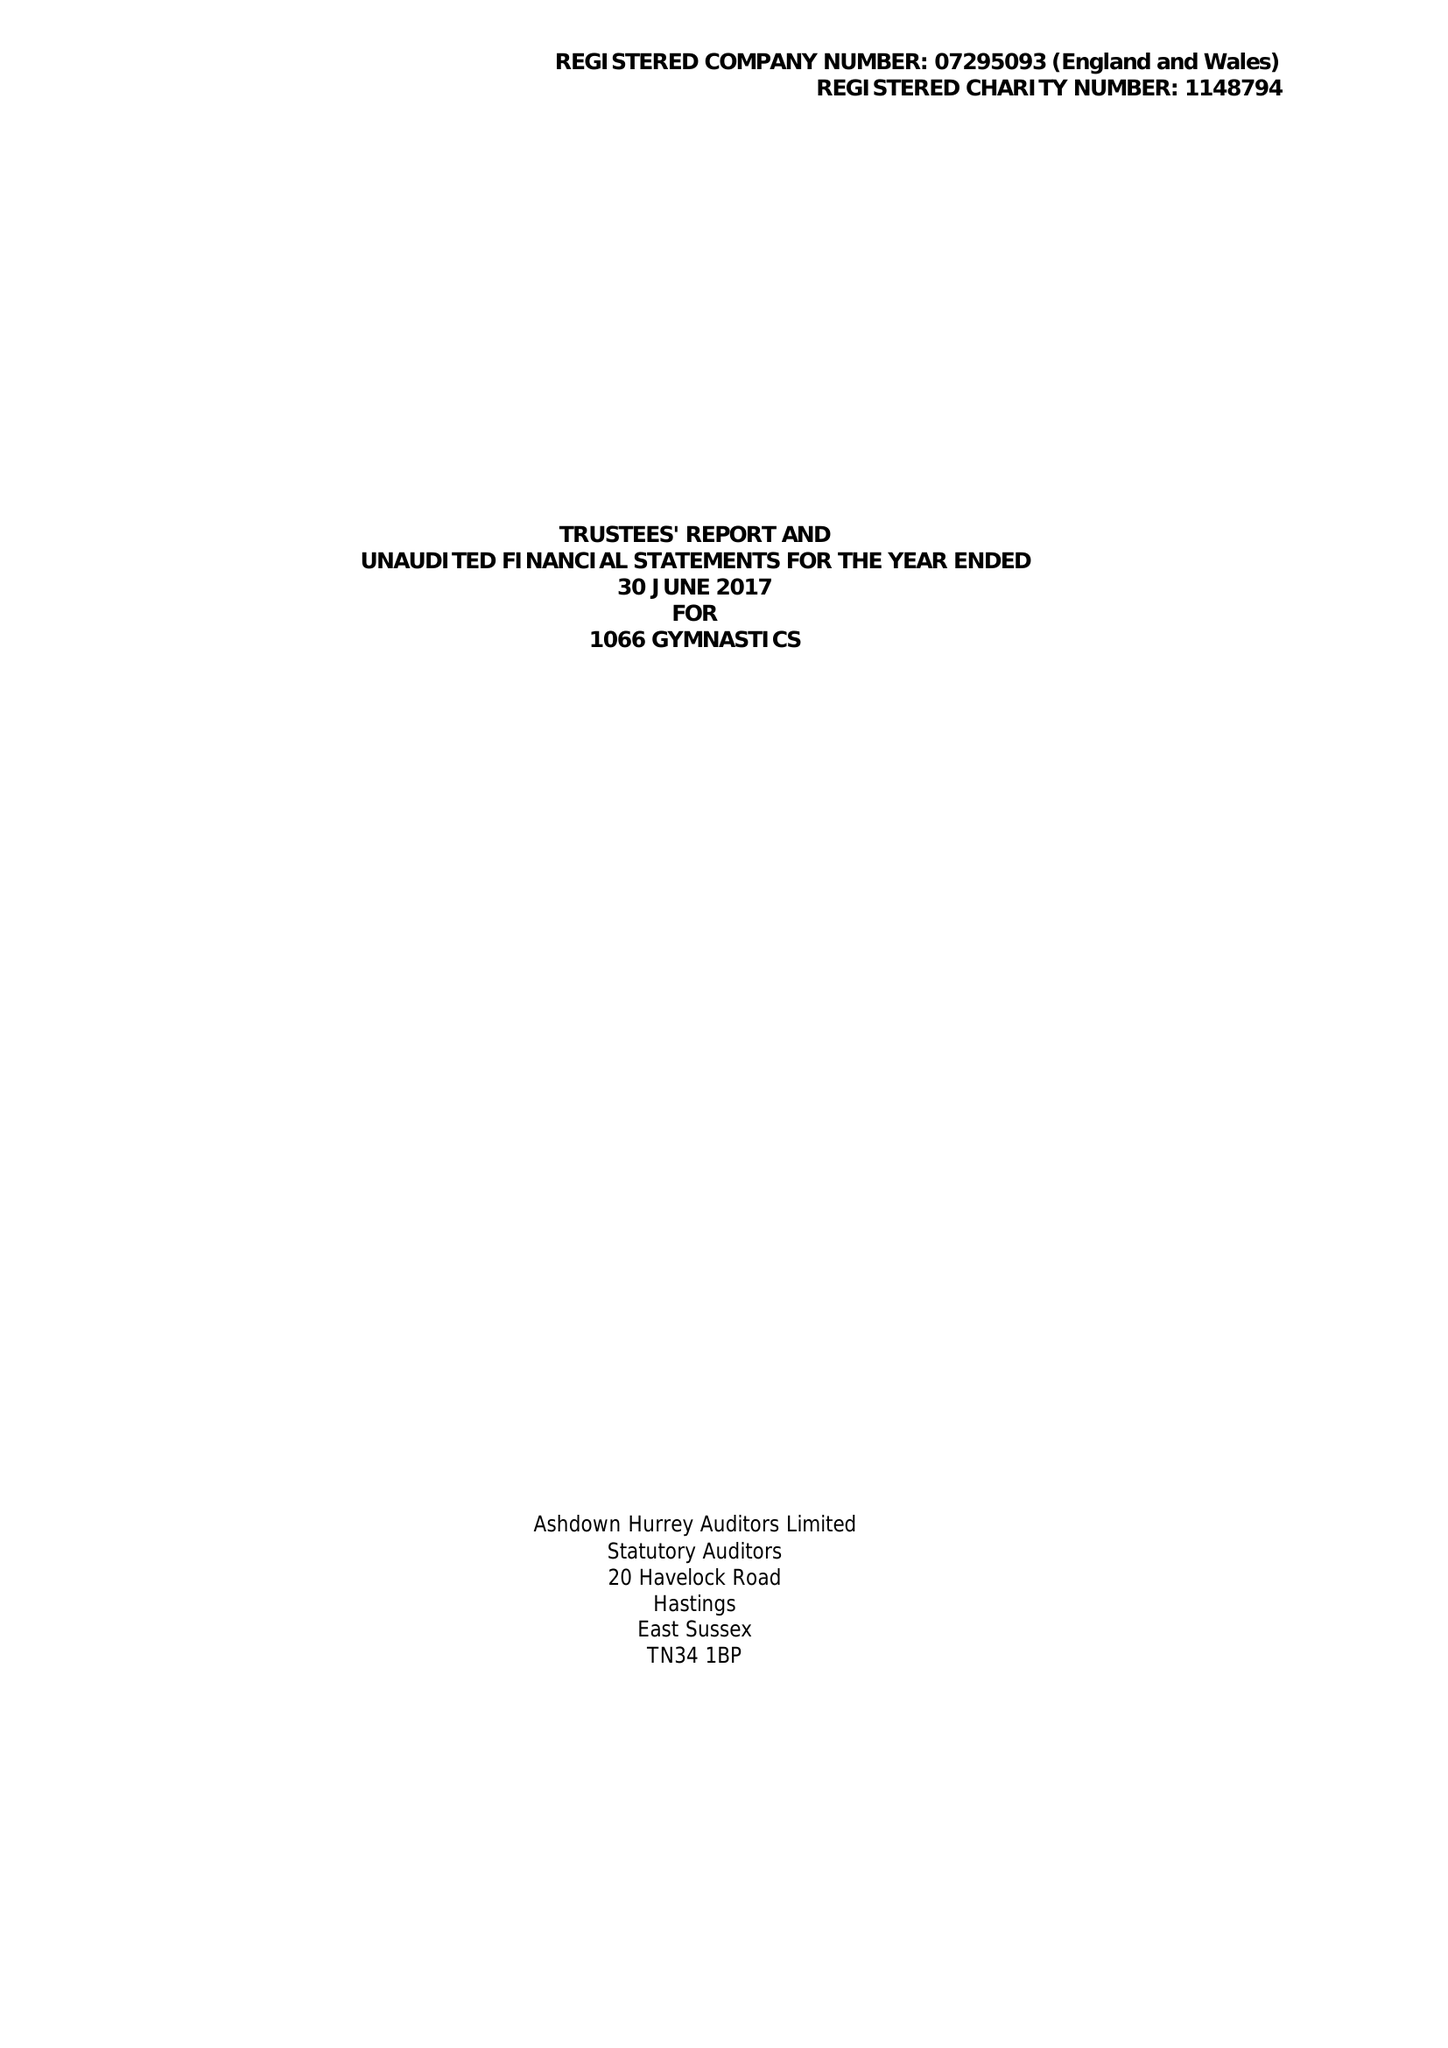What is the value for the address__postcode?
Answer the question using a single word or phrase. TN40 2JP 